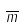Convert formula to latex. <formula><loc_0><loc_0><loc_500><loc_500>\overline { m }</formula> 